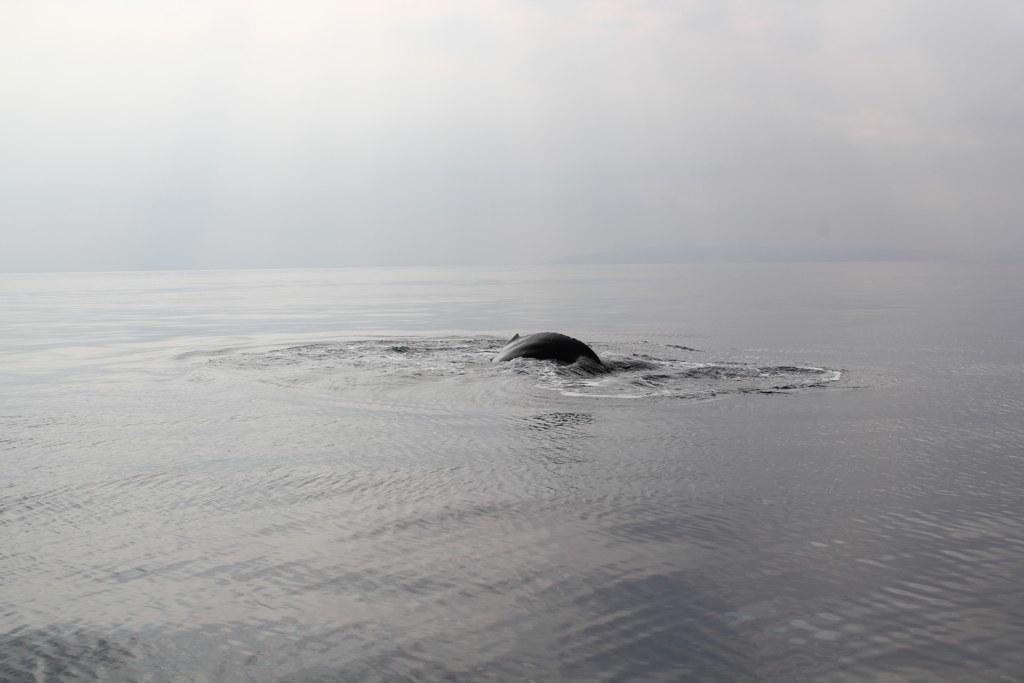Can you describe this image briefly? In this image in the center it looks like a shark, at the bottom there is a river and at the top there is sky. 